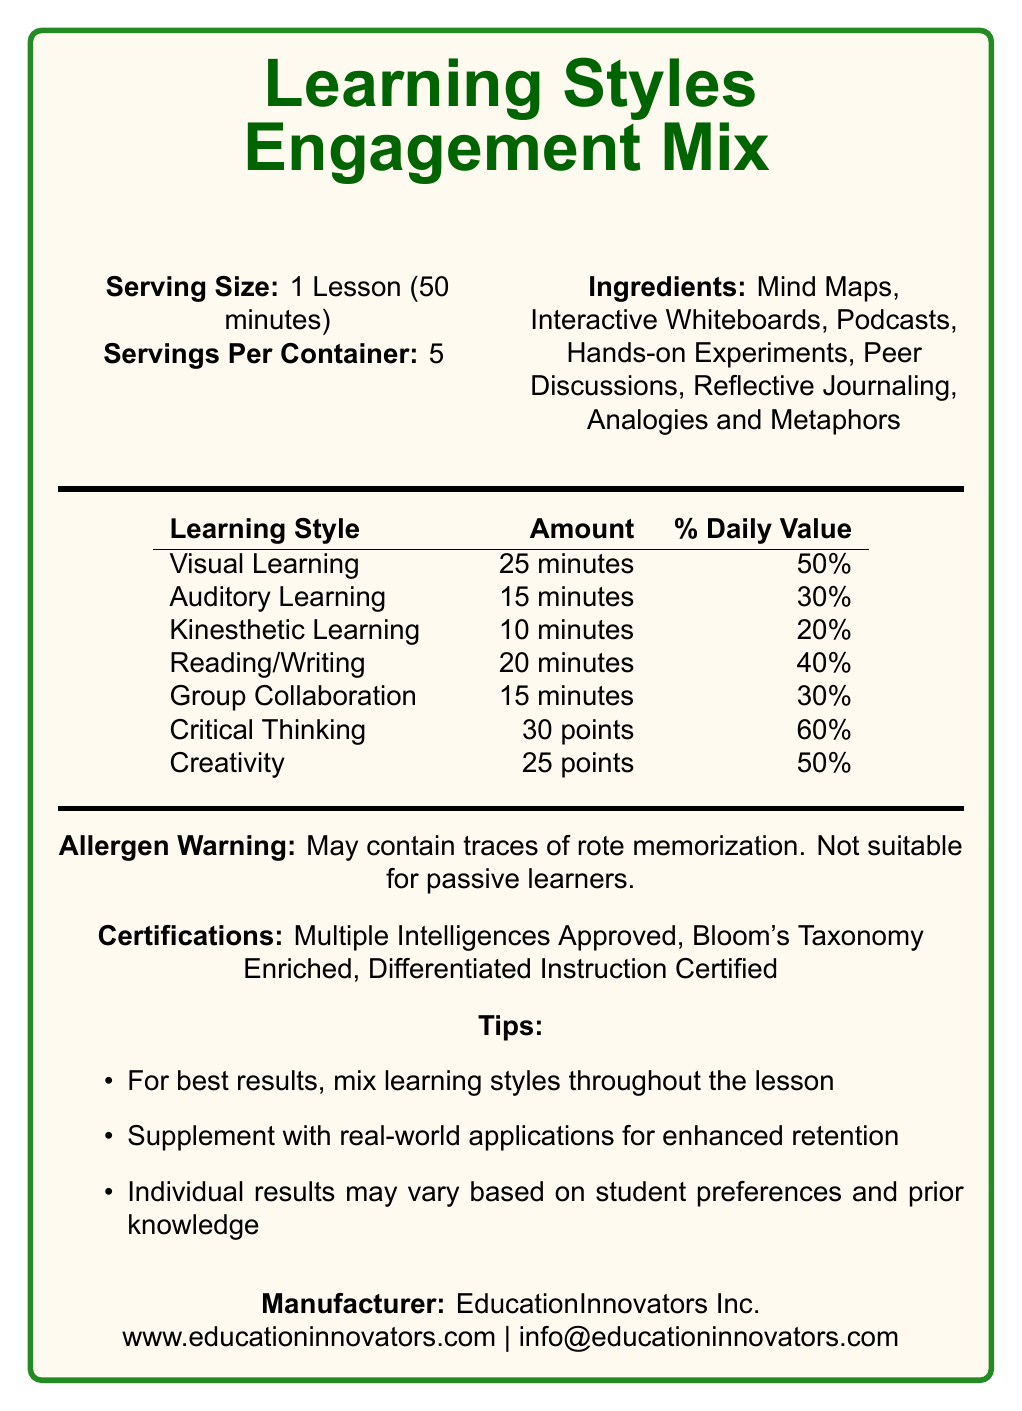What is the serving size mentioned in the document? The document explicitly states that the serving size is 1 Lesson (50 minutes) under the "Serving Size" section.
Answer: 1 Lesson (50 minutes) How many servings per container are there? The document lists 5 servings per container under the "Servings Per Container" section.
Answer: 5 Which learning style has the highest daily value percentage? According to the nutritional content table, Critical Thinking has a daily value percentage of 60%.
Answer: Critical Thinking What ingredients are included in the product? The document lists these ingredients under the "Ingredients" section.
Answer: Mind Maps, Interactive Whiteboards, Podcasts, Hands-on Experiments, Peer Discussions, Reflective Journaling, Analogies and Metaphors What are the certifications this product has received? The certifications are mentioned in the "Certifications" section.
Answer: Multiple Intelligences Approved, Bloom's Taxonomy Enriched, Differentiated Instruction Certified Which learning style is allocated 20 minutes per lesson? The content table clearly mentions that the Reading/Writing learning style is allocated 20 minutes per lesson.
Answer: Reading/Writing For which student group is this product not suitable according to the allergen warning? The allergen warning states, "Not suitable for passive learners."
Answer: Passive learners What is the total amount of time allocated to different learning styles per lesson in minutes? Adding up the minutes for Visual Learning (25), Auditory Learning (15), Kinesthetic Learning (10), Reading/Writing (20), and Group Collaboration (15) gives a total of 85 minutes.
Answer: 85 minutes Which organization manufactures this product? The manufacturer's name is stated in the "Manufacturer" section.
Answer: EducationInnovators Inc. Can the effectiveness of the product vary based on student preferences? One of the tips mentions, "Individual results may vary based on student preferences."
Answer: Yes Which of the following is not listed as an ingredient? 
A. Podcasts
B. Videos
C. Peer Discussions
D. Reflective Journaling Videos is not listed as an ingredient according to the document; the others are mentioned.
Answer: B. Videos What percent daily value does Creativity have? 
I. 20%
II. 30%
III. 50%
IV. 60% The nutritional content table shows that Creativity has a daily value percentage of 50%.
Answer: III. 50% Does the document mention anything about nutritional content for logical-mathematical learning? The document does not include any information about a logical-mathematical learning style.
Answer: No Summarize the main idea of the document. The document aims to present an educational product in the format of a nutrition label to highlight how different learning styles and techniques can be balanced and used effectively for student engagement.
Answer: The document describes a "Learning Styles Engagement Mix" for student engagement, listing various learning styles with specific time allocations and daily value percentages. It includes ingredients beneficial for learning, allergen warnings, certifications, tips for best use, and manufacturer information. What is the manufacturer's contact email? The document provides the manufacturer's contact email in the "Manufacturer" section.
Answer: info@educationinnovators.com How many points are allocated to Critical Thinking per lesson? The nutritional content for Critical Thinking shows 30 points per lesson.
Answer: 30 points Which learning style is allocated the least amount of time? The nutritional content table allocates the least amount of time to Kinesthetic Learning with 10 minutes.
Answer: Kinesthetic Learning What supplements does the document suggest for enhanced retention? One of the tips mentions to, "Supplement with real-world applications for enhanced retention."
Answer: Real-world applications Which organization enriches the product according to its certifications?
A. International Baccalaureate
B. Bloom's Taxonomy
C. Montessori Method
D. Reggio Emilia Approach The certification section indicates that the product is "Bloom's Taxonomy Enriched."
Answer: B. Bloom's Taxonomy Can the document provide information about the visual representation of the ingredients? The visual representation of the ingredients is not provided in the document; it only lists the ingredients.
Answer: Cannot be determined 